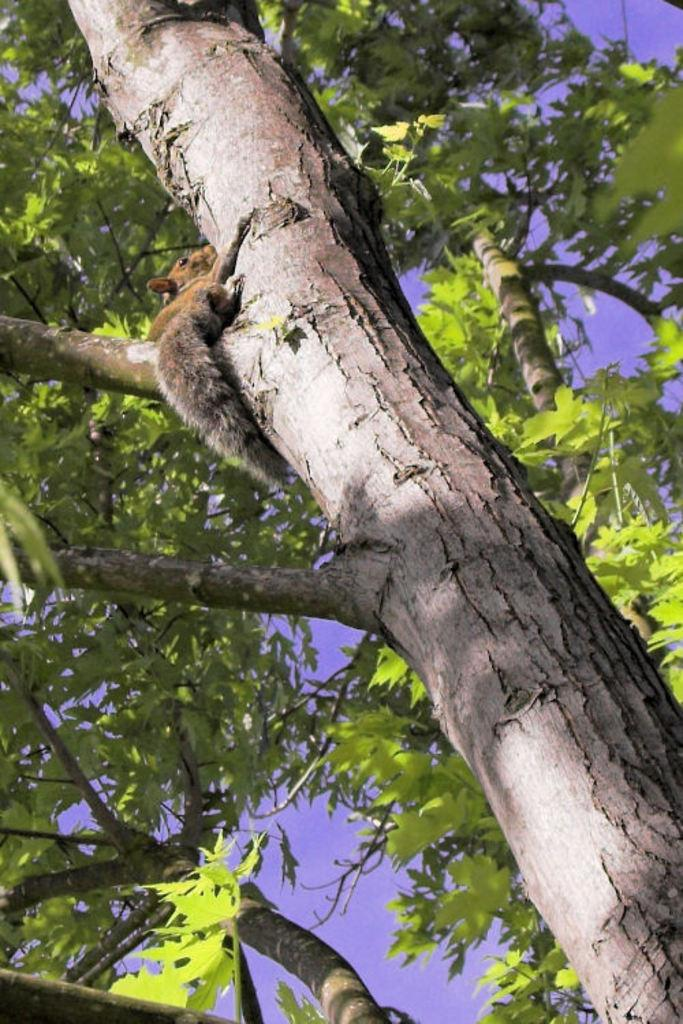What is the main subject of the image? There is an animal on a tree in the image. What can be seen in the background of the image? There are branches visible in the background. What part of the natural environment is visible in the image? The sky is visible in the image. What invention can be seen in the hands of the lawyer in the image? There is no lawyer or invention present in the image; it features an animal on a tree with visible branches and sky. 